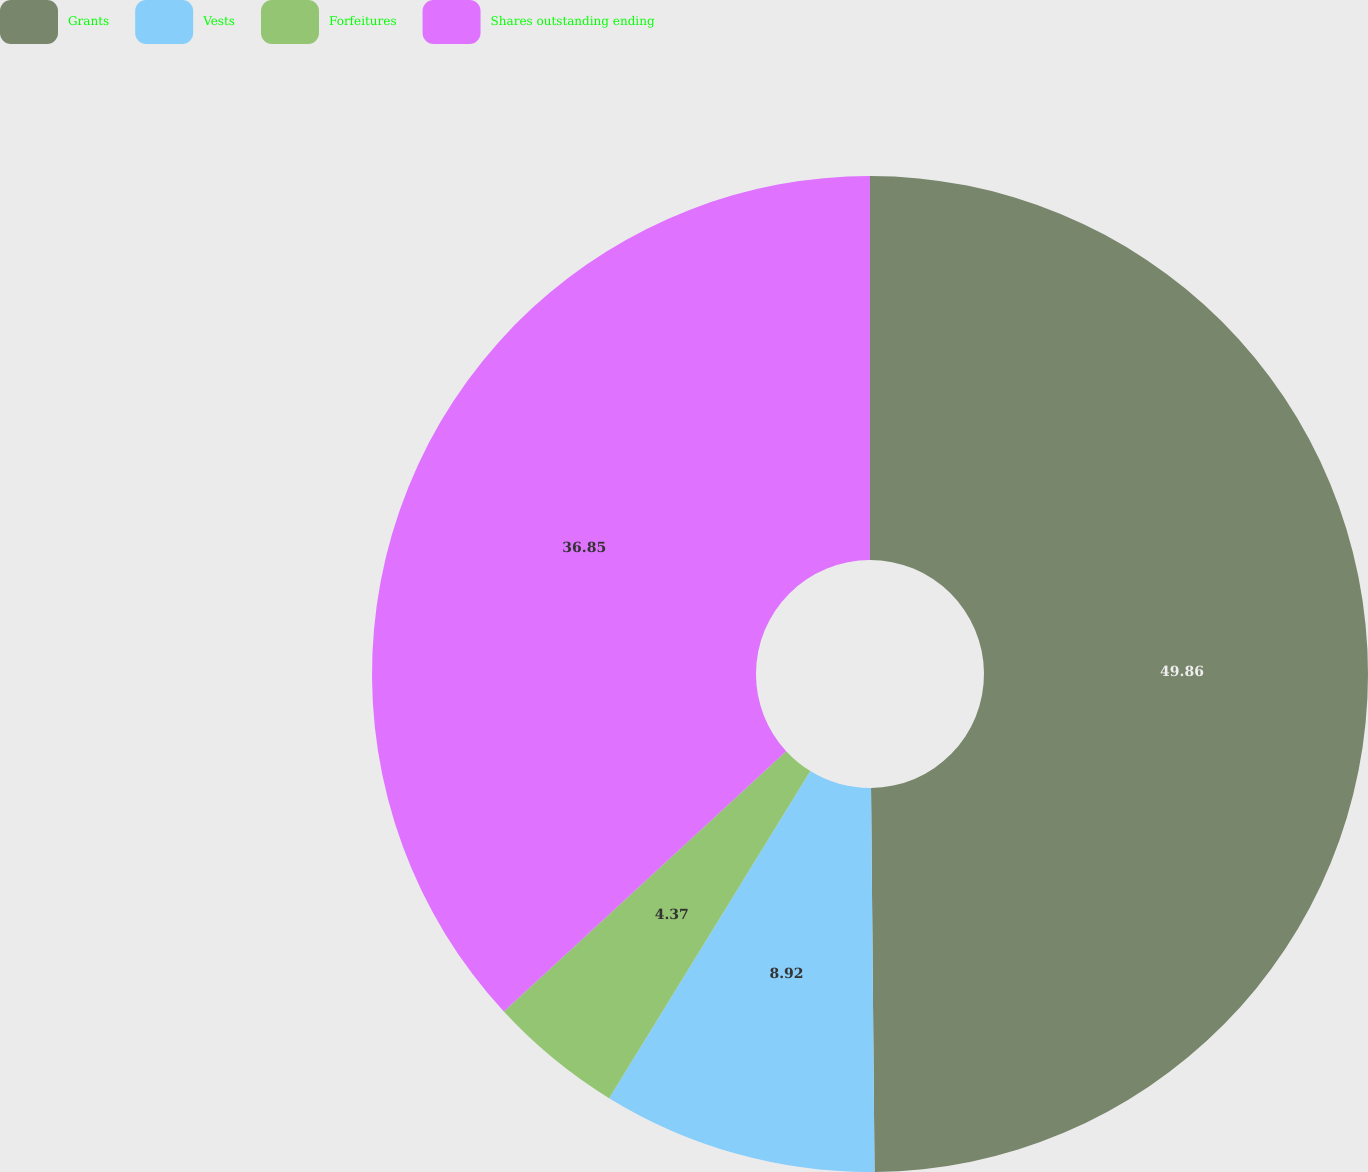Convert chart to OTSL. <chart><loc_0><loc_0><loc_500><loc_500><pie_chart><fcel>Grants<fcel>Vests<fcel>Forfeitures<fcel>Shares outstanding ending<nl><fcel>49.85%<fcel>8.92%<fcel>4.37%<fcel>36.85%<nl></chart> 